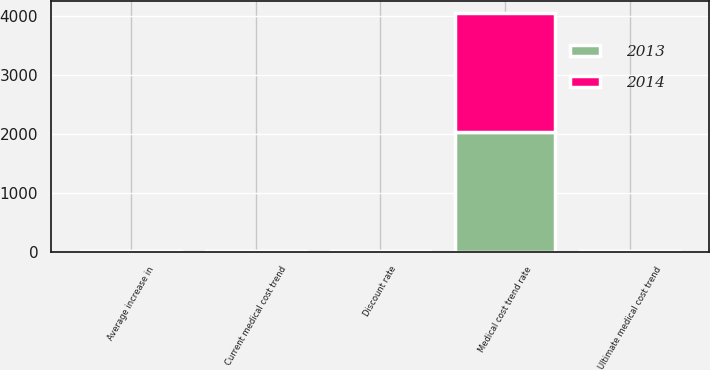Convert chart. <chart><loc_0><loc_0><loc_500><loc_500><stacked_bar_chart><ecel><fcel>Discount rate<fcel>Average increase in<fcel>Current medical cost trend<fcel>Ultimate medical cost trend<fcel>Medical cost trend rate<nl><fcel>2013<fcel>4<fcel>3.5<fcel>8<fcel>3.5<fcel>2028<nl><fcel>2014<fcel>4.5<fcel>3.5<fcel>9<fcel>3.5<fcel>2028<nl></chart> 